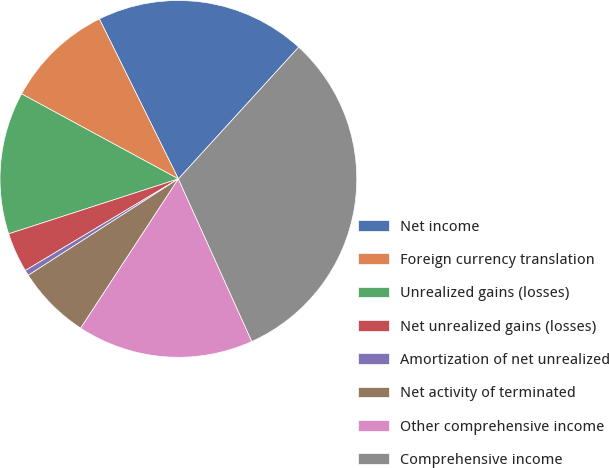<chart> <loc_0><loc_0><loc_500><loc_500><pie_chart><fcel>Net income<fcel>Foreign currency translation<fcel>Unrealized gains (losses)<fcel>Net unrealized gains (losses)<fcel>Amortization of net unrealized<fcel>Net activity of terminated<fcel>Other comprehensive income<fcel>Comprehensive income<nl><fcel>19.08%<fcel>9.79%<fcel>12.89%<fcel>3.6%<fcel>0.5%<fcel>6.69%<fcel>15.98%<fcel>31.47%<nl></chart> 